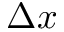Convert formula to latex. <formula><loc_0><loc_0><loc_500><loc_500>\Delta x</formula> 